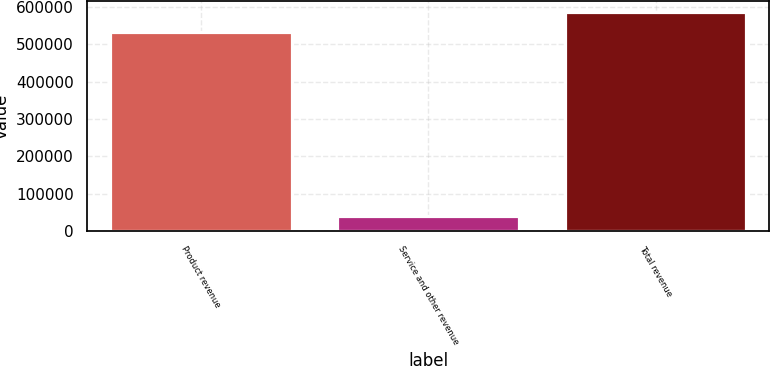Convert chart to OTSL. <chart><loc_0><loc_0><loc_500><loc_500><bar_chart><fcel>Product revenue<fcel>Service and other revenue<fcel>Total revenue<nl><fcel>532390<fcel>40835<fcel>585629<nl></chart> 